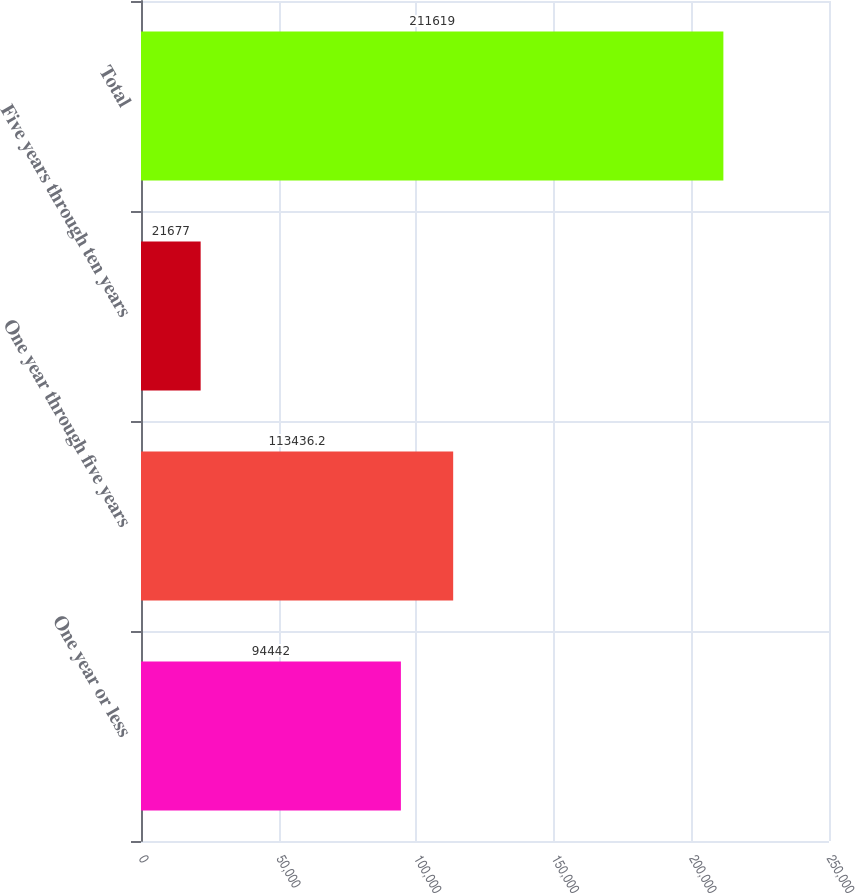Convert chart. <chart><loc_0><loc_0><loc_500><loc_500><bar_chart><fcel>One year or less<fcel>One year through five years<fcel>Five years through ten years<fcel>Total<nl><fcel>94442<fcel>113436<fcel>21677<fcel>211619<nl></chart> 